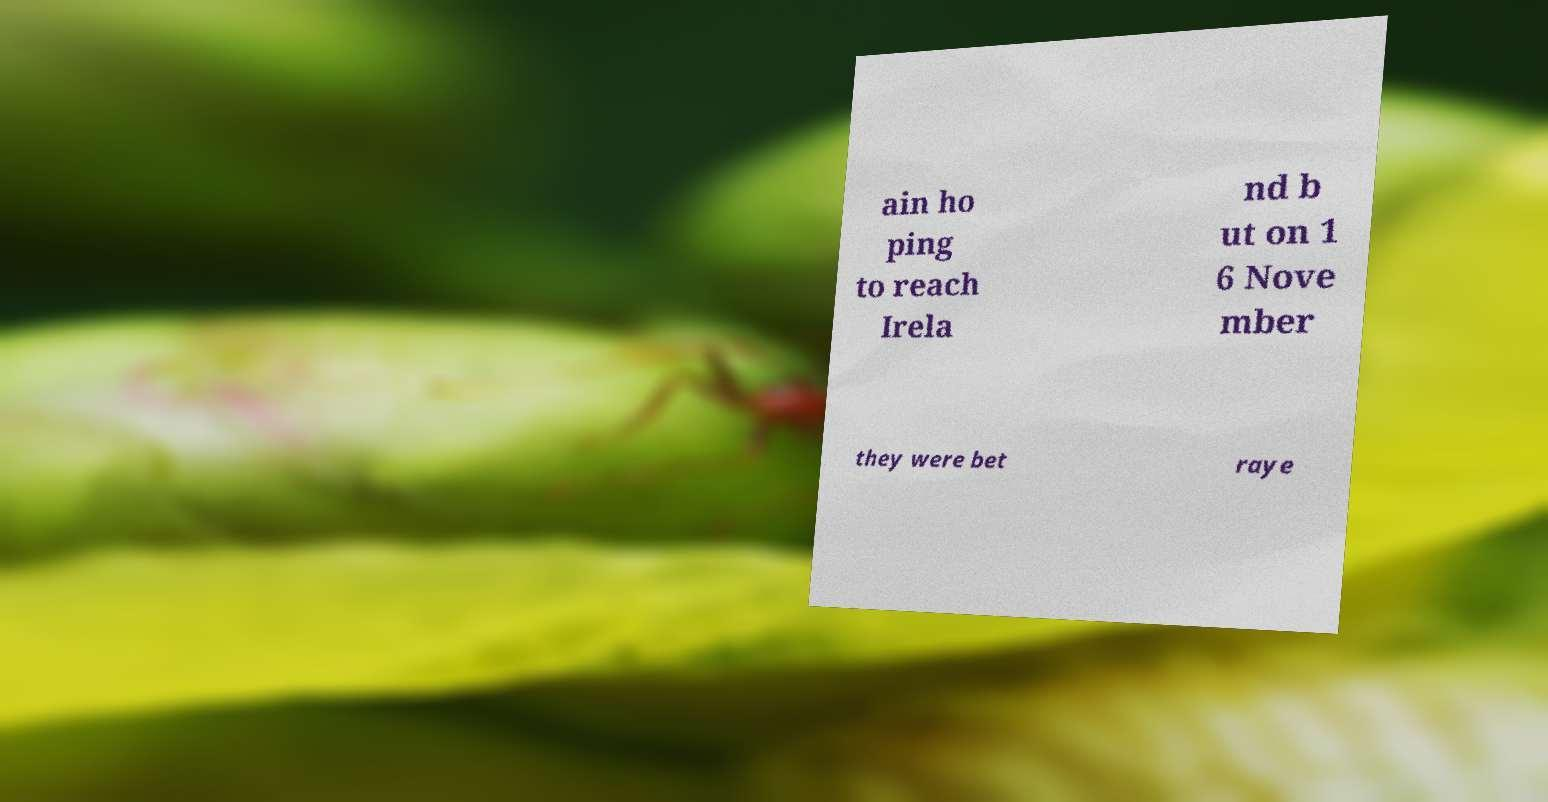Please identify and transcribe the text found in this image. ain ho ping to reach Irela nd b ut on 1 6 Nove mber they were bet raye 